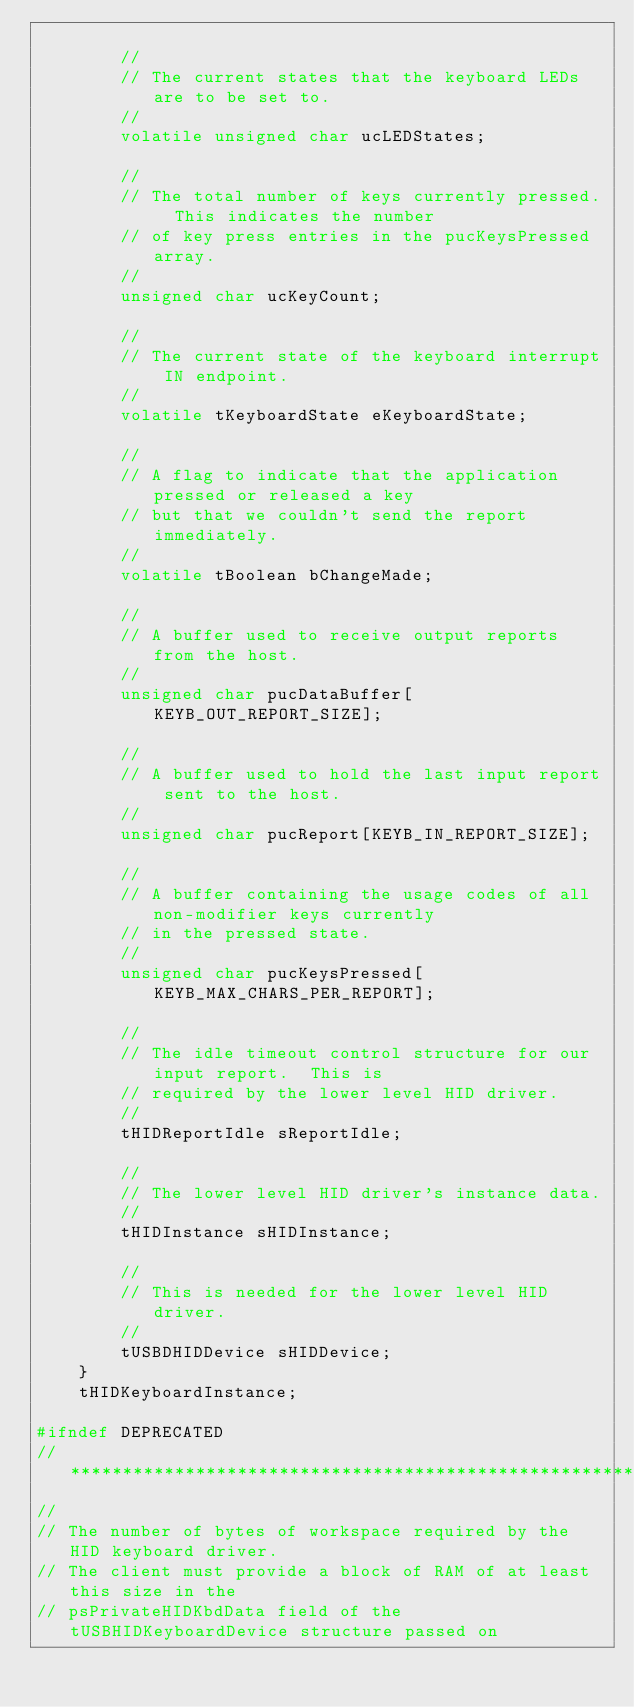<code> <loc_0><loc_0><loc_500><loc_500><_C_>
        //
        // The current states that the keyboard LEDs are to be set to.
        //
        volatile unsigned char ucLEDStates;

        //
        // The total number of keys currently pressed.  This indicates the number
        // of key press entries in the pucKeysPressed array.
        //
        unsigned char ucKeyCount;

        //
        // The current state of the keyboard interrupt IN endpoint.
        //
        volatile tKeyboardState eKeyboardState;

        //
        // A flag to indicate that the application pressed or released a key
        // but that we couldn't send the report immediately.
        //
        volatile tBoolean bChangeMade;

        //
        // A buffer used to receive output reports from the host.
        //
        unsigned char pucDataBuffer[KEYB_OUT_REPORT_SIZE];

        //
        // A buffer used to hold the last input report sent to the host.
        //
        unsigned char pucReport[KEYB_IN_REPORT_SIZE];

        //
        // A buffer containing the usage codes of all non-modifier keys currently
        // in the pressed state.
        //
        unsigned char pucKeysPressed[KEYB_MAX_CHARS_PER_REPORT];

        //
        // The idle timeout control structure for our input report.  This is
        // required by the lower level HID driver.
        //
        tHIDReportIdle sReportIdle;

        //
        // The lower level HID driver's instance data.
        //
        tHIDInstance sHIDInstance;

        //
        // This is needed for the lower level HID driver.
        //
        tUSBDHIDDevice sHIDDevice;
    }
    tHIDKeyboardInstance;

#ifndef DEPRECATED
//*****************************************************************************
//
// The number of bytes of workspace required by the HID keyboard driver.
// The client must provide a block of RAM of at least this size in the
// psPrivateHIDKbdData field of the tUSBHIDKeyboardDevice structure passed on</code> 